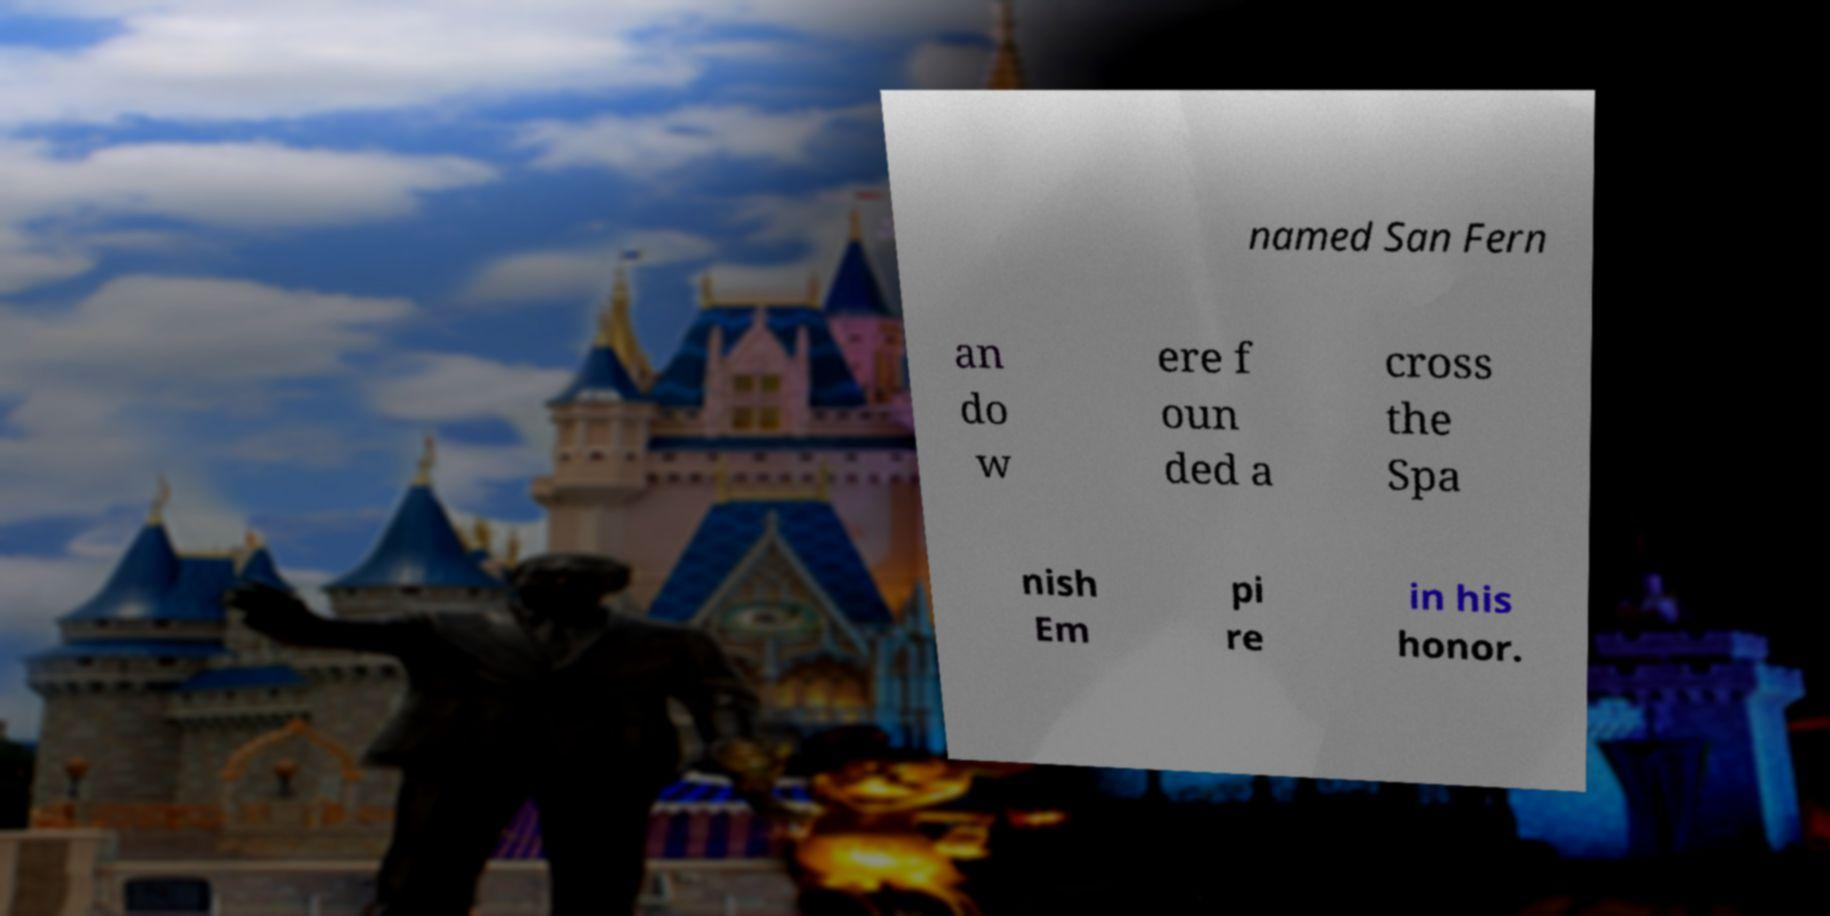For documentation purposes, I need the text within this image transcribed. Could you provide that? named San Fern an do w ere f oun ded a cross the Spa nish Em pi re in his honor. 